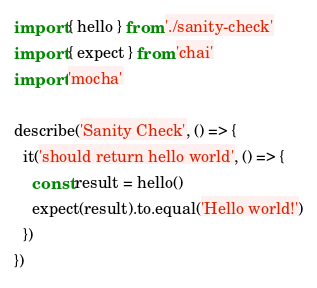<code> <loc_0><loc_0><loc_500><loc_500><_TypeScript_>import { hello } from './sanity-check'
import { expect } from 'chai'
import 'mocha'

describe('Sanity Check', () => {
  it('should return hello world', () => {
    const result = hello()
    expect(result).to.equal('Hello world!')
  })
})
</code> 